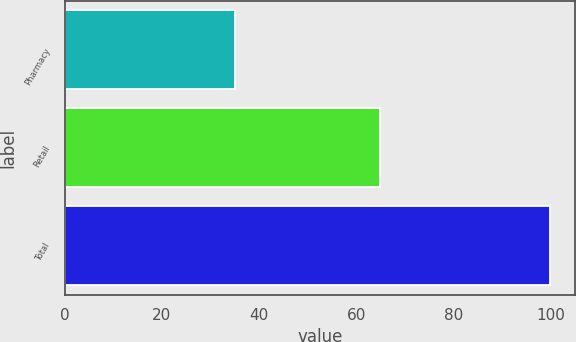Convert chart to OTSL. <chart><loc_0><loc_0><loc_500><loc_500><bar_chart><fcel>Pharmacy<fcel>Retail<fcel>Total<nl><fcel>35<fcel>65<fcel>100<nl></chart> 